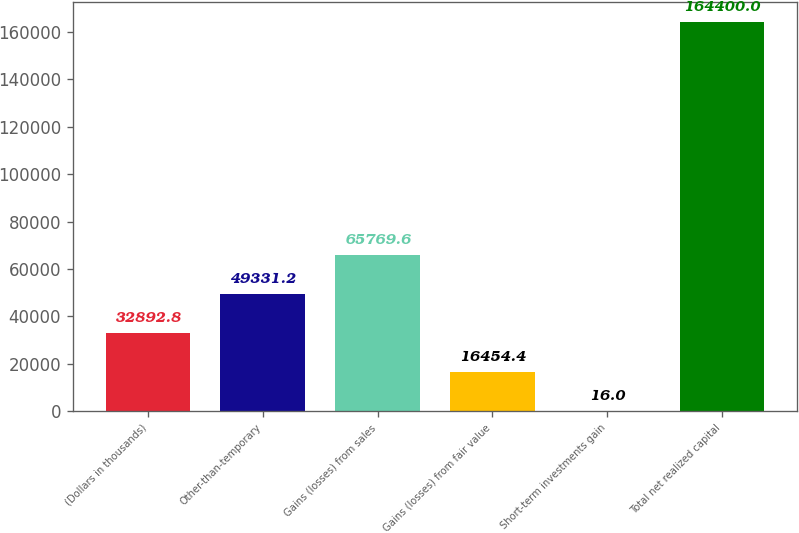Convert chart to OTSL. <chart><loc_0><loc_0><loc_500><loc_500><bar_chart><fcel>(Dollars in thousands)<fcel>Other-than-temporary<fcel>Gains (losses) from sales<fcel>Gains (losses) from fair value<fcel>Short-term investments gain<fcel>Total net realized capital<nl><fcel>32892.8<fcel>49331.2<fcel>65769.6<fcel>16454.4<fcel>16<fcel>164400<nl></chart> 